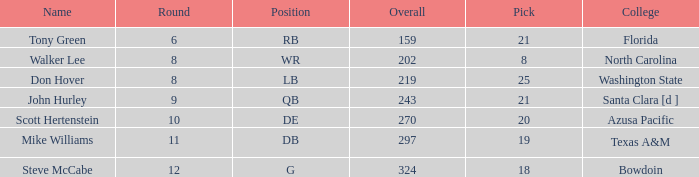Which college has a pick less than 25, an overall greater than 159, a round less than 10, and wr as the position? North Carolina. 